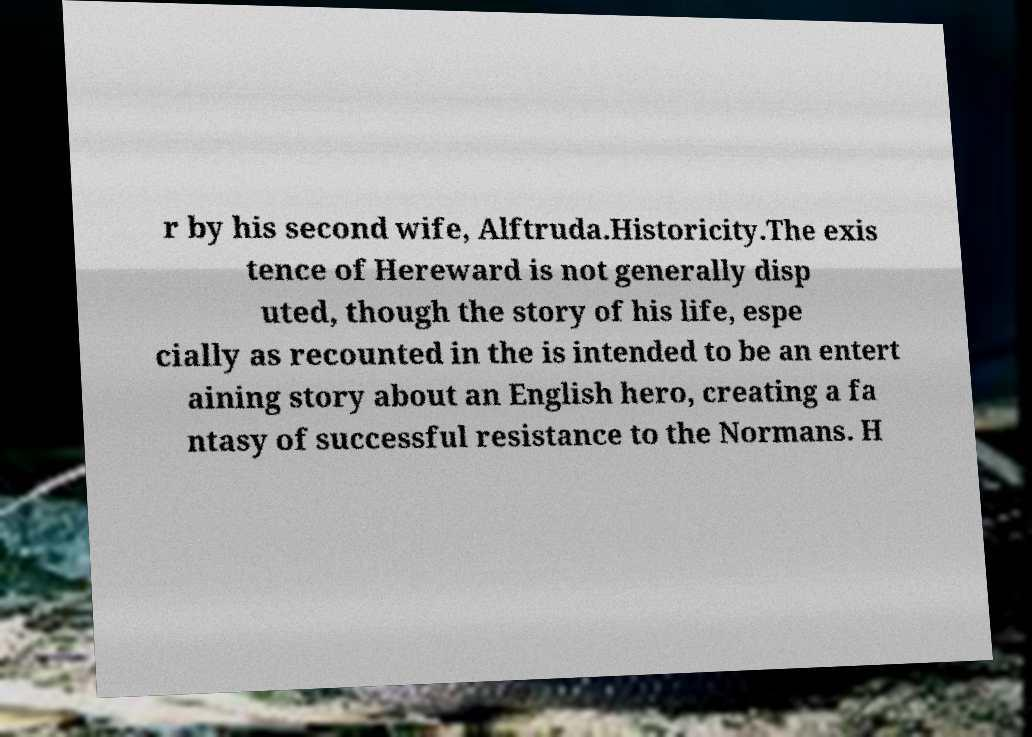What messages or text are displayed in this image? I need them in a readable, typed format. r by his second wife, Alftruda.Historicity.The exis tence of Hereward is not generally disp uted, though the story of his life, espe cially as recounted in the is intended to be an entert aining story about an English hero, creating a fa ntasy of successful resistance to the Normans. H 